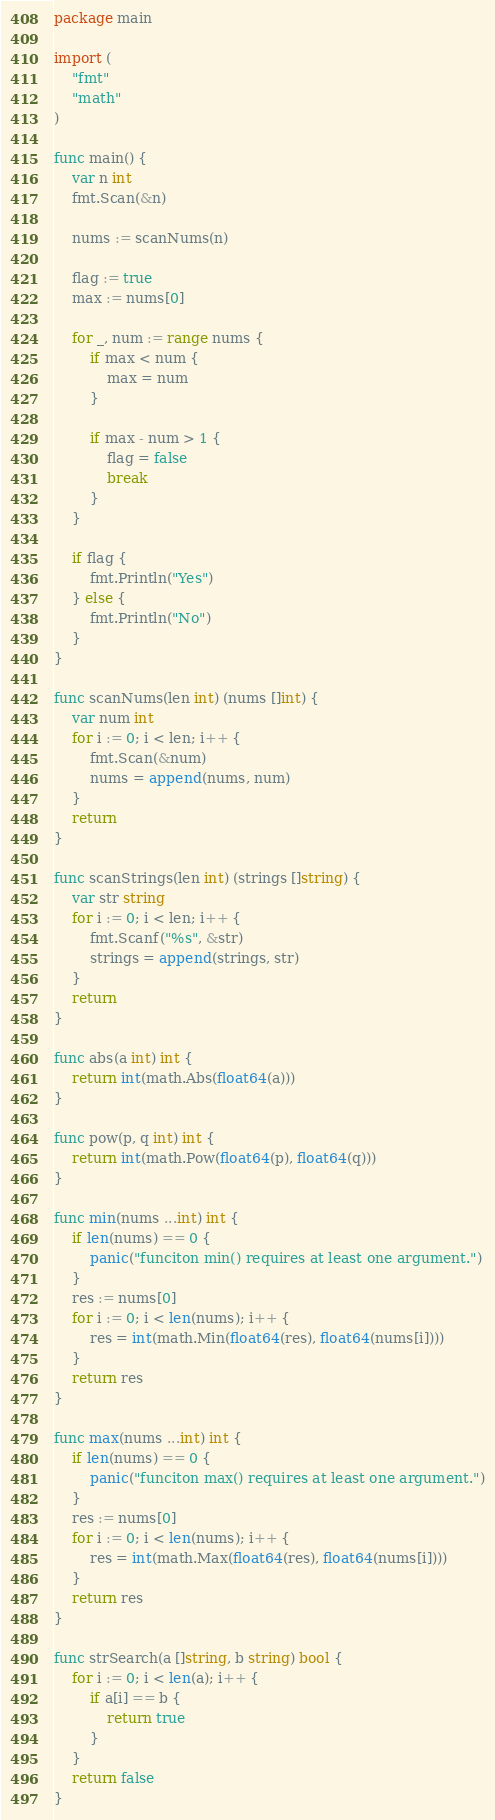Convert code to text. <code><loc_0><loc_0><loc_500><loc_500><_Go_>package main

import (
	"fmt"
	"math"
)

func main() {
	var n int
	fmt.Scan(&n)

	nums := scanNums(n)

	flag := true
	max := nums[0]

	for _, num := range nums {
		if max < num {
			max = num
		}

		if max - num > 1 {
			flag = false
			break
		}
	}

	if flag {
		fmt.Println("Yes")
	} else {
		fmt.Println("No")
	}
}

func scanNums(len int) (nums []int) {
	var num int
	for i := 0; i < len; i++ {
		fmt.Scan(&num)
		nums = append(nums, num)
	}
	return
}

func scanStrings(len int) (strings []string) {
	var str string
	for i := 0; i < len; i++ {
		fmt.Scanf("%s", &str)
		strings = append(strings, str)
	}
	return
}

func abs(a int) int {
	return int(math.Abs(float64(a)))
}

func pow(p, q int) int {
	return int(math.Pow(float64(p), float64(q)))
}

func min(nums ...int) int {
	if len(nums) == 0 {
		panic("funciton min() requires at least one argument.")
	}
	res := nums[0]
	for i := 0; i < len(nums); i++ {
		res = int(math.Min(float64(res), float64(nums[i])))
	}
	return res
}

func max(nums ...int) int {
	if len(nums) == 0 {
		panic("funciton max() requires at least one argument.")
	}
	res := nums[0]
	for i := 0; i < len(nums); i++ {
		res = int(math.Max(float64(res), float64(nums[i])))
	}
	return res
}

func strSearch(a []string, b string) bool {
	for i := 0; i < len(a); i++ {
		if a[i] == b {
			return true
		}
	}
	return false
}
</code> 